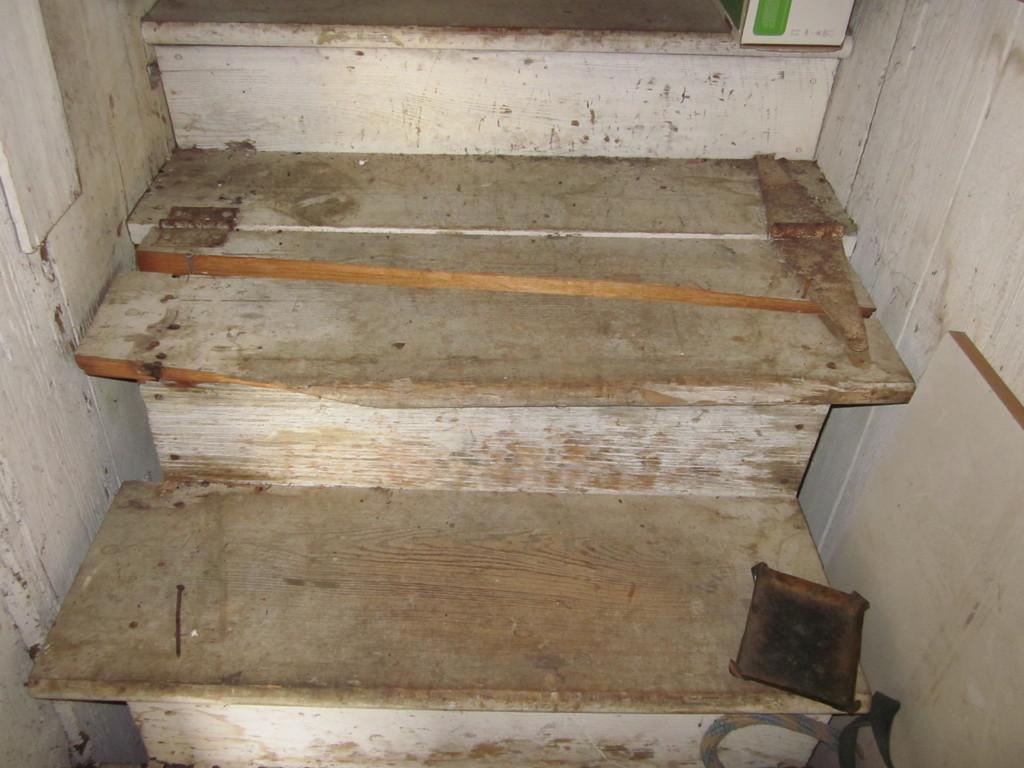Could you give a brief overview of what you see in this image? In this image I can see stairs and over here I can see an iron nail. I can also see few other stuffs over here. 